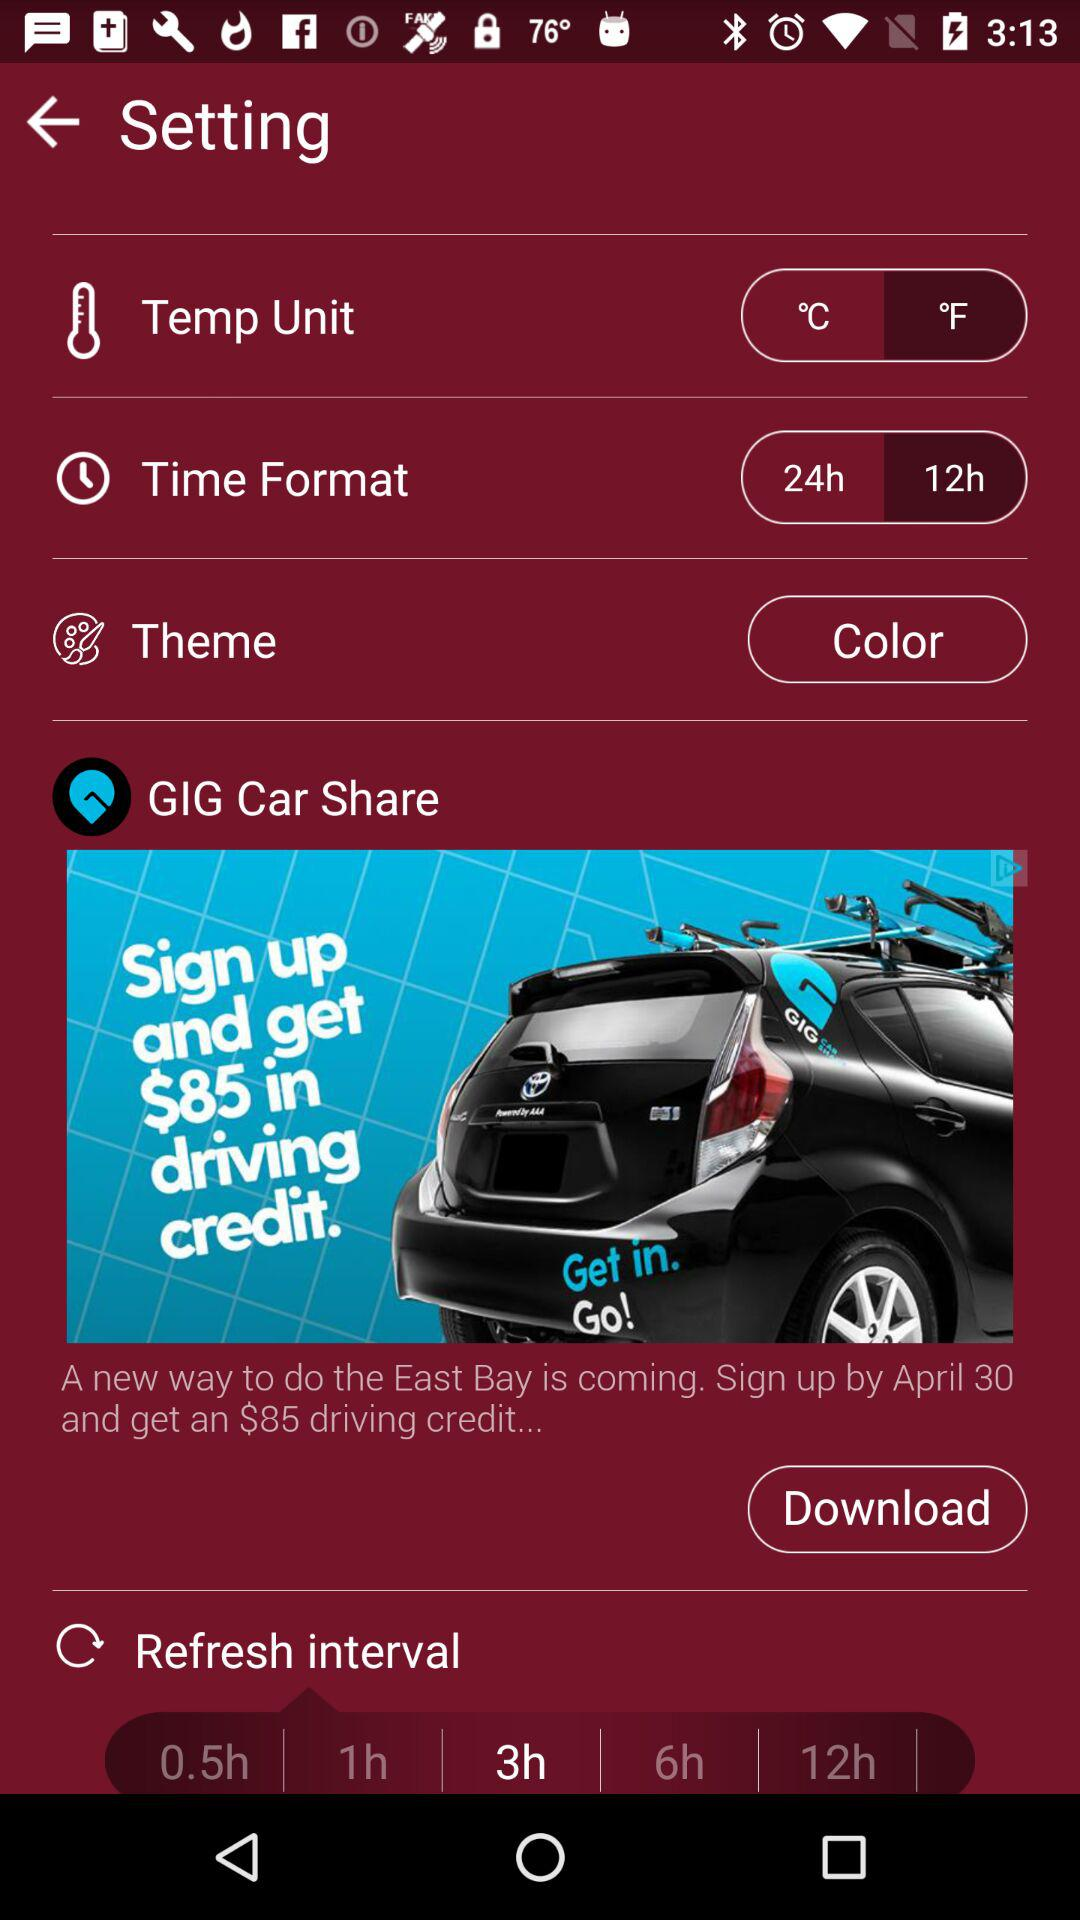What is the selected temperature unit? The selected temperature unit is "°F". 